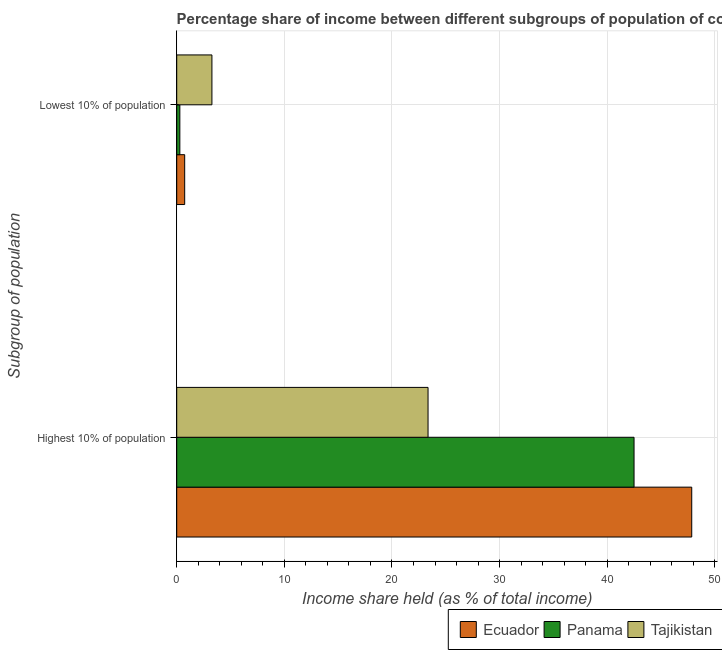How many different coloured bars are there?
Your answer should be compact. 3. How many groups of bars are there?
Provide a succinct answer. 2. Are the number of bars on each tick of the Y-axis equal?
Provide a short and direct response. Yes. How many bars are there on the 1st tick from the bottom?
Offer a very short reply. 3. What is the label of the 2nd group of bars from the top?
Make the answer very short. Highest 10% of population. What is the income share held by lowest 10% of the population in Tajikistan?
Provide a succinct answer. 3.27. Across all countries, what is the maximum income share held by highest 10% of the population?
Provide a short and direct response. 47.85. Across all countries, what is the minimum income share held by lowest 10% of the population?
Offer a terse response. 0.29. In which country was the income share held by highest 10% of the population maximum?
Your answer should be compact. Ecuador. In which country was the income share held by lowest 10% of the population minimum?
Your answer should be compact. Panama. What is the total income share held by lowest 10% of the population in the graph?
Provide a succinct answer. 4.3. What is the difference between the income share held by highest 10% of the population in Tajikistan and that in Panama?
Offer a very short reply. -19.14. What is the difference between the income share held by lowest 10% of the population in Tajikistan and the income share held by highest 10% of the population in Panama?
Ensure brevity in your answer.  -39.22. What is the average income share held by highest 10% of the population per country?
Ensure brevity in your answer.  37.9. What is the difference between the income share held by lowest 10% of the population and income share held by highest 10% of the population in Ecuador?
Make the answer very short. -47.11. What is the ratio of the income share held by highest 10% of the population in Ecuador to that in Panama?
Your answer should be compact. 1.13. In how many countries, is the income share held by lowest 10% of the population greater than the average income share held by lowest 10% of the population taken over all countries?
Ensure brevity in your answer.  1. What does the 1st bar from the top in Lowest 10% of population represents?
Your response must be concise. Tajikistan. What does the 1st bar from the bottom in Lowest 10% of population represents?
Provide a short and direct response. Ecuador. How many bars are there?
Provide a short and direct response. 6. How many countries are there in the graph?
Give a very brief answer. 3. Does the graph contain any zero values?
Your answer should be very brief. No. How many legend labels are there?
Ensure brevity in your answer.  3. What is the title of the graph?
Ensure brevity in your answer.  Percentage share of income between different subgroups of population of countries. Does "Thailand" appear as one of the legend labels in the graph?
Ensure brevity in your answer.  No. What is the label or title of the X-axis?
Ensure brevity in your answer.  Income share held (as % of total income). What is the label or title of the Y-axis?
Your response must be concise. Subgroup of population. What is the Income share held (as % of total income) in Ecuador in Highest 10% of population?
Offer a very short reply. 47.85. What is the Income share held (as % of total income) in Panama in Highest 10% of population?
Make the answer very short. 42.49. What is the Income share held (as % of total income) in Tajikistan in Highest 10% of population?
Your response must be concise. 23.35. What is the Income share held (as % of total income) in Ecuador in Lowest 10% of population?
Your answer should be very brief. 0.74. What is the Income share held (as % of total income) in Panama in Lowest 10% of population?
Offer a very short reply. 0.29. What is the Income share held (as % of total income) in Tajikistan in Lowest 10% of population?
Keep it short and to the point. 3.27. Across all Subgroup of population, what is the maximum Income share held (as % of total income) in Ecuador?
Your response must be concise. 47.85. Across all Subgroup of population, what is the maximum Income share held (as % of total income) in Panama?
Provide a succinct answer. 42.49. Across all Subgroup of population, what is the maximum Income share held (as % of total income) of Tajikistan?
Your answer should be compact. 23.35. Across all Subgroup of population, what is the minimum Income share held (as % of total income) of Ecuador?
Keep it short and to the point. 0.74. Across all Subgroup of population, what is the minimum Income share held (as % of total income) in Panama?
Offer a terse response. 0.29. Across all Subgroup of population, what is the minimum Income share held (as % of total income) of Tajikistan?
Provide a short and direct response. 3.27. What is the total Income share held (as % of total income) of Ecuador in the graph?
Ensure brevity in your answer.  48.59. What is the total Income share held (as % of total income) of Panama in the graph?
Ensure brevity in your answer.  42.78. What is the total Income share held (as % of total income) of Tajikistan in the graph?
Your response must be concise. 26.62. What is the difference between the Income share held (as % of total income) in Ecuador in Highest 10% of population and that in Lowest 10% of population?
Your response must be concise. 47.11. What is the difference between the Income share held (as % of total income) of Panama in Highest 10% of population and that in Lowest 10% of population?
Your answer should be compact. 42.2. What is the difference between the Income share held (as % of total income) of Tajikistan in Highest 10% of population and that in Lowest 10% of population?
Ensure brevity in your answer.  20.08. What is the difference between the Income share held (as % of total income) of Ecuador in Highest 10% of population and the Income share held (as % of total income) of Panama in Lowest 10% of population?
Ensure brevity in your answer.  47.56. What is the difference between the Income share held (as % of total income) in Ecuador in Highest 10% of population and the Income share held (as % of total income) in Tajikistan in Lowest 10% of population?
Ensure brevity in your answer.  44.58. What is the difference between the Income share held (as % of total income) of Panama in Highest 10% of population and the Income share held (as % of total income) of Tajikistan in Lowest 10% of population?
Provide a succinct answer. 39.22. What is the average Income share held (as % of total income) in Ecuador per Subgroup of population?
Your answer should be compact. 24.3. What is the average Income share held (as % of total income) in Panama per Subgroup of population?
Your response must be concise. 21.39. What is the average Income share held (as % of total income) of Tajikistan per Subgroup of population?
Ensure brevity in your answer.  13.31. What is the difference between the Income share held (as % of total income) of Ecuador and Income share held (as % of total income) of Panama in Highest 10% of population?
Ensure brevity in your answer.  5.36. What is the difference between the Income share held (as % of total income) in Panama and Income share held (as % of total income) in Tajikistan in Highest 10% of population?
Offer a very short reply. 19.14. What is the difference between the Income share held (as % of total income) in Ecuador and Income share held (as % of total income) in Panama in Lowest 10% of population?
Ensure brevity in your answer.  0.45. What is the difference between the Income share held (as % of total income) of Ecuador and Income share held (as % of total income) of Tajikistan in Lowest 10% of population?
Your response must be concise. -2.53. What is the difference between the Income share held (as % of total income) in Panama and Income share held (as % of total income) in Tajikistan in Lowest 10% of population?
Keep it short and to the point. -2.98. What is the ratio of the Income share held (as % of total income) in Ecuador in Highest 10% of population to that in Lowest 10% of population?
Give a very brief answer. 64.66. What is the ratio of the Income share held (as % of total income) of Panama in Highest 10% of population to that in Lowest 10% of population?
Your answer should be very brief. 146.52. What is the ratio of the Income share held (as % of total income) in Tajikistan in Highest 10% of population to that in Lowest 10% of population?
Provide a succinct answer. 7.14. What is the difference between the highest and the second highest Income share held (as % of total income) in Ecuador?
Your response must be concise. 47.11. What is the difference between the highest and the second highest Income share held (as % of total income) in Panama?
Your response must be concise. 42.2. What is the difference between the highest and the second highest Income share held (as % of total income) in Tajikistan?
Offer a very short reply. 20.08. What is the difference between the highest and the lowest Income share held (as % of total income) of Ecuador?
Offer a terse response. 47.11. What is the difference between the highest and the lowest Income share held (as % of total income) in Panama?
Make the answer very short. 42.2. What is the difference between the highest and the lowest Income share held (as % of total income) of Tajikistan?
Your response must be concise. 20.08. 